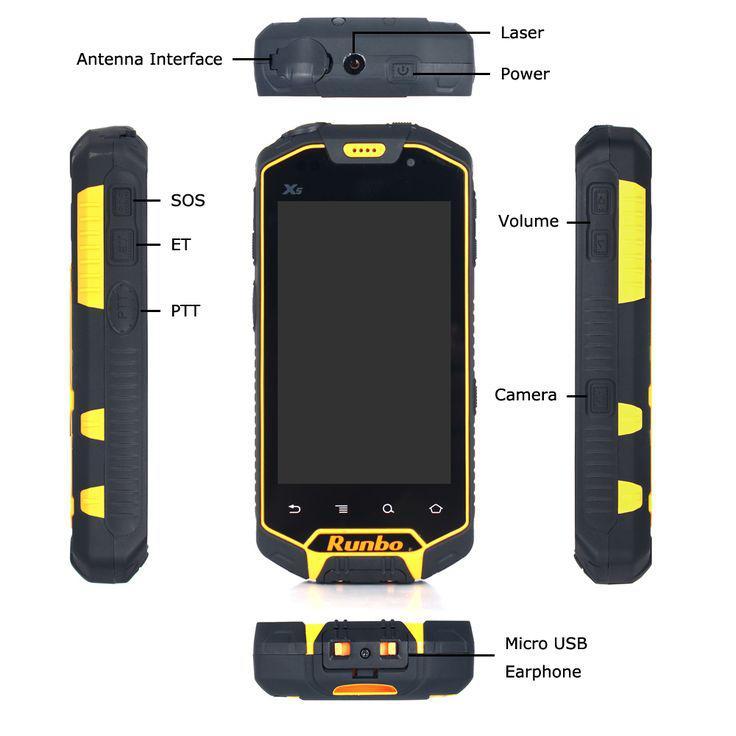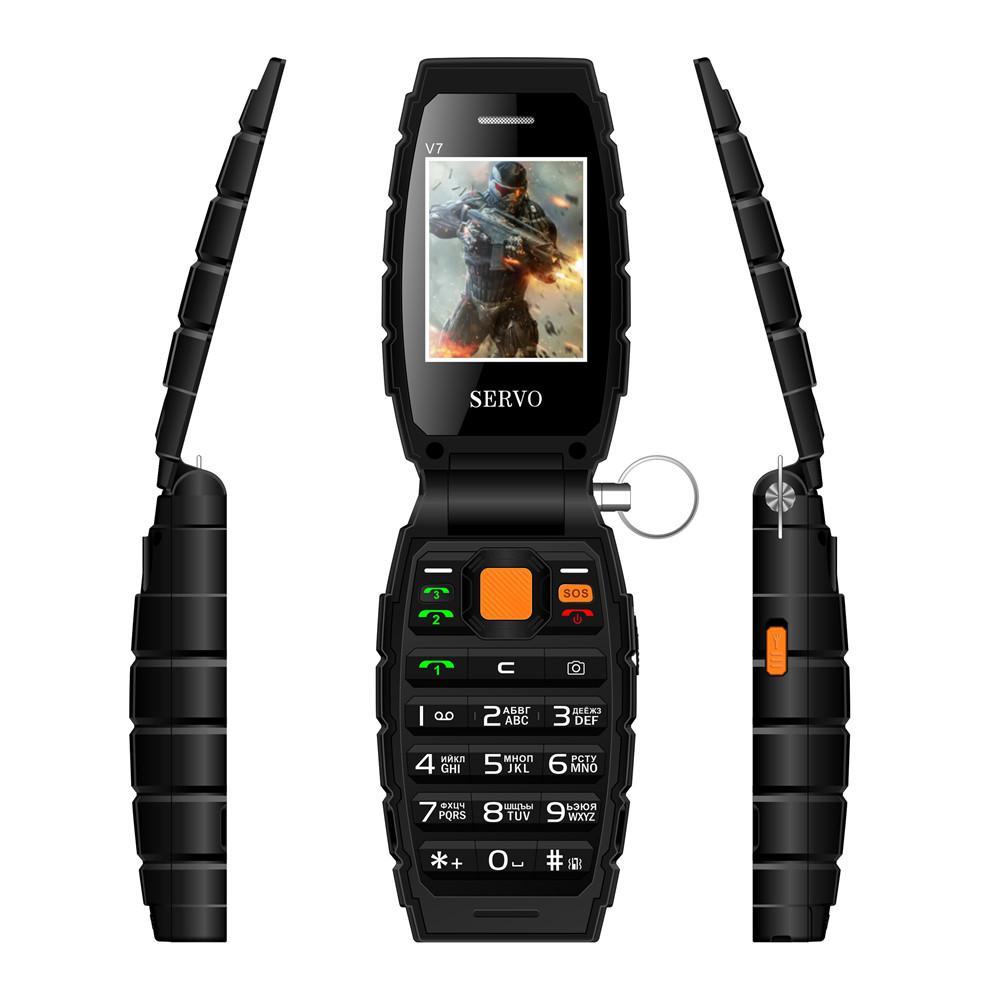The first image is the image on the left, the second image is the image on the right. Examine the images to the left and right. Is the description "One of the phones shows an image of four people in a sunset." accurate? Answer yes or no. No. The first image is the image on the left, the second image is the image on the right. Considering the images on both sides, is "One image features a grenade-look flip phone with a round 'pin' on its side, and the phone is shown flipped open in at least a forward and a side view." valid? Answer yes or no. Yes. 